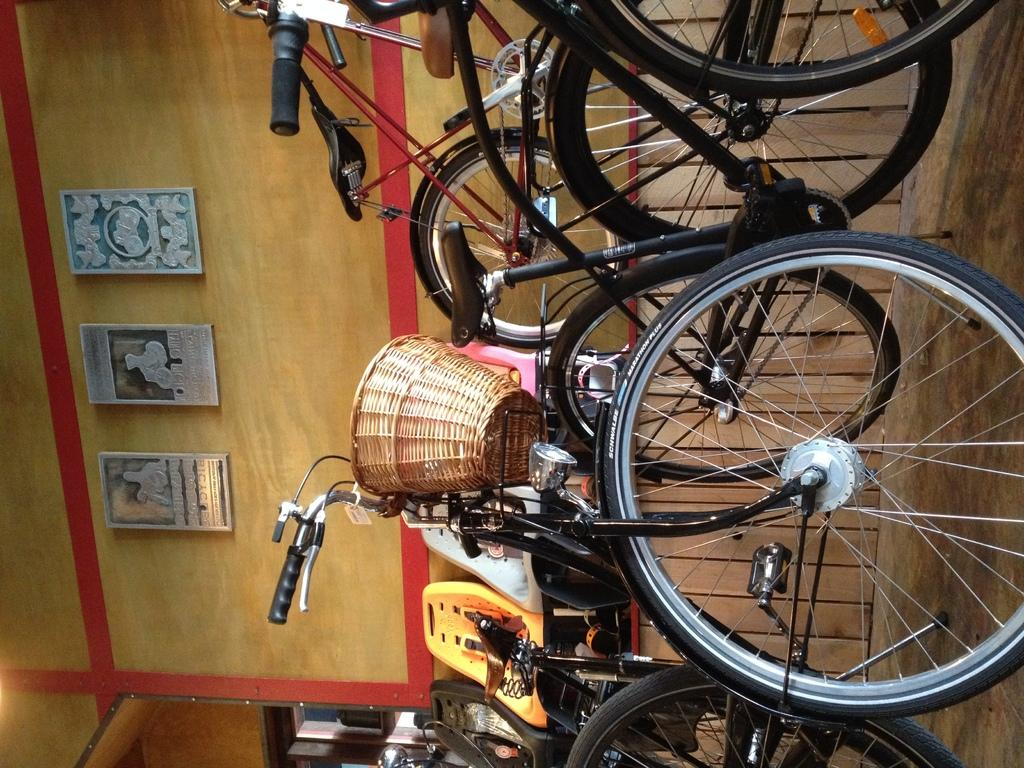What is the person in the image doing with a pin? There is no pin present in the image. What type of disease can be seen in the image? There is no disease visible in the image. What behavior is the person in the image exhibiting? The person in the image is typing on a computer, which suggests they are engaged in a task that requires typing. What type of behavior is the pin exhibiting in the image? There is no pin present in the image, so it cannot exhibit any behavior. 